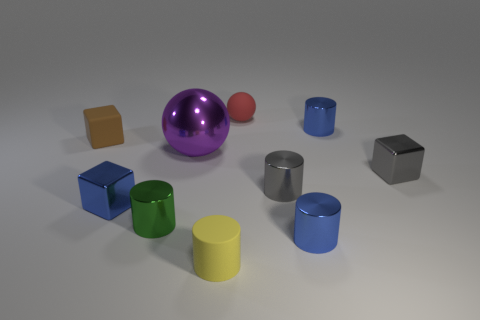How many tiny things are either blue objects or matte cylinders?
Offer a very short reply. 4. There is another object that is the same shape as the purple object; what is it made of?
Make the answer very short. Rubber. Is there anything else that has the same material as the tiny ball?
Keep it short and to the point. Yes. The tiny matte cylinder is what color?
Provide a succinct answer. Yellow. Is the tiny ball the same color as the small matte cylinder?
Your response must be concise. No. There is a small blue cylinder that is behind the purple metallic ball; how many small shiny cylinders are in front of it?
Give a very brief answer. 3. There is a blue object that is both in front of the large purple thing and to the right of the yellow object; what size is it?
Offer a very short reply. Small. There is a tiny blue thing that is left of the green metallic cylinder; what is its material?
Your answer should be very brief. Metal. Is there a tiny green object of the same shape as the tiny yellow matte thing?
Your response must be concise. Yes. How many small gray metallic objects have the same shape as the brown thing?
Give a very brief answer. 1. 